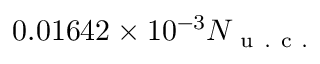Convert formula to latex. <formula><loc_0><loc_0><loc_500><loc_500>0 . 0 1 6 4 2 \times 1 0 ^ { - 3 } N _ { u . c . }</formula> 